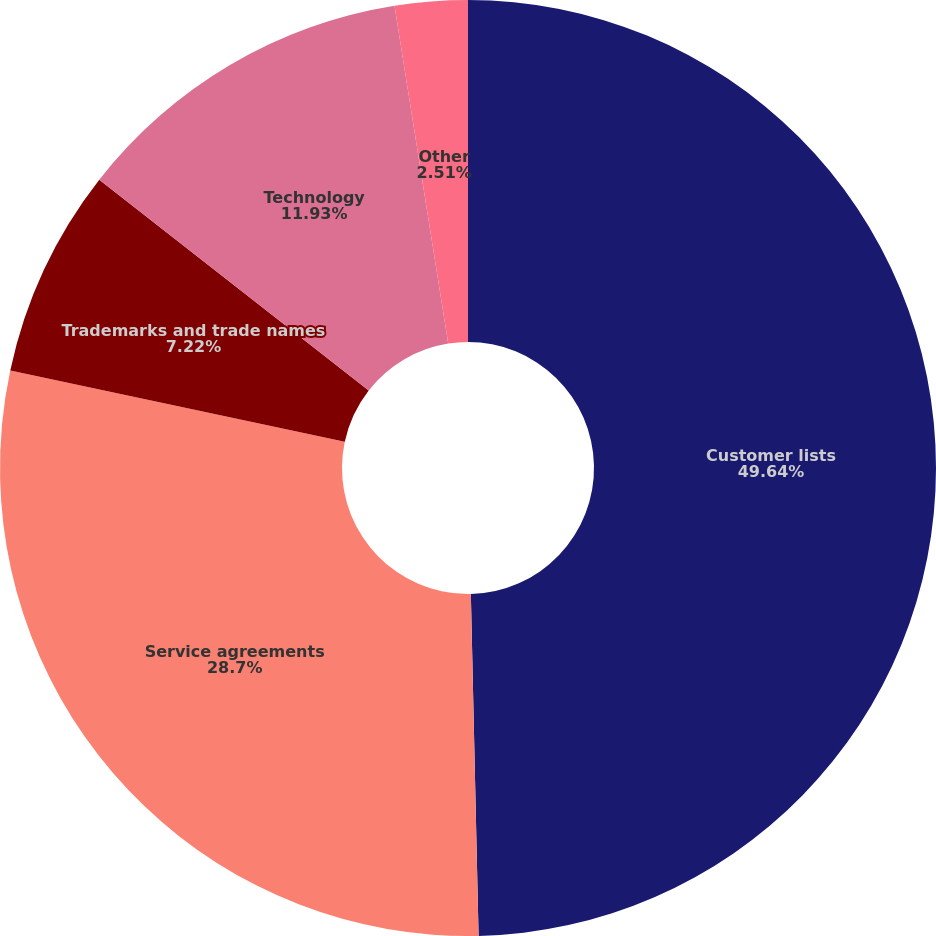Convert chart to OTSL. <chart><loc_0><loc_0><loc_500><loc_500><pie_chart><fcel>Customer lists<fcel>Service agreements<fcel>Trademarks and trade names<fcel>Technology<fcel>Other<nl><fcel>49.64%<fcel>28.7%<fcel>7.22%<fcel>11.93%<fcel>2.51%<nl></chart> 